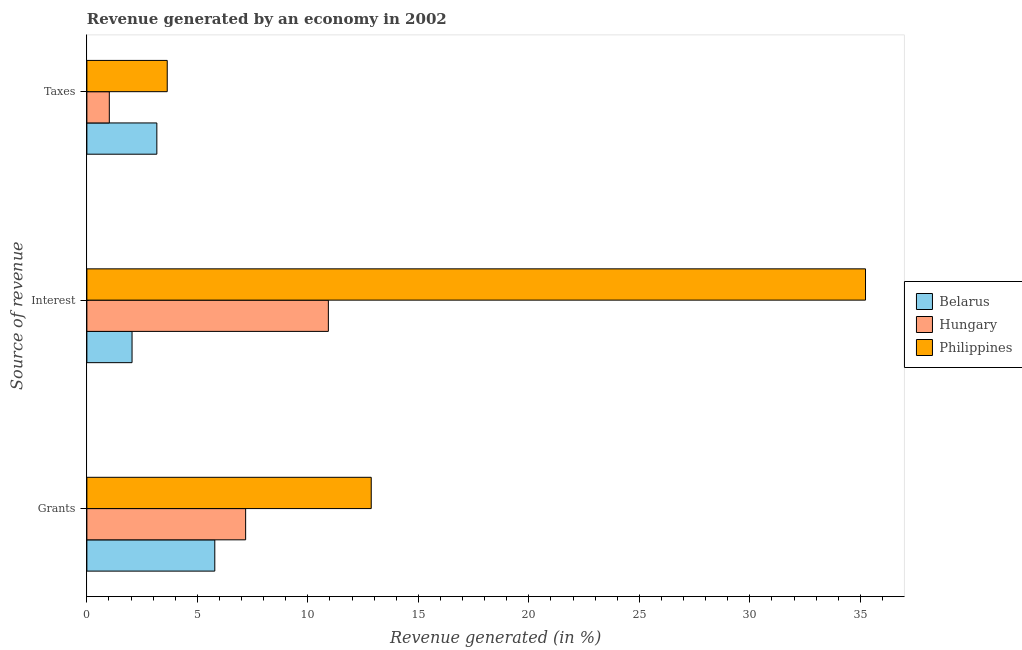How many different coloured bars are there?
Your answer should be very brief. 3. How many groups of bars are there?
Ensure brevity in your answer.  3. How many bars are there on the 1st tick from the bottom?
Give a very brief answer. 3. What is the label of the 1st group of bars from the top?
Provide a short and direct response. Taxes. What is the percentage of revenue generated by grants in Philippines?
Your answer should be compact. 12.87. Across all countries, what is the maximum percentage of revenue generated by taxes?
Your answer should be compact. 3.64. Across all countries, what is the minimum percentage of revenue generated by grants?
Keep it short and to the point. 5.79. In which country was the percentage of revenue generated by interest maximum?
Ensure brevity in your answer.  Philippines. In which country was the percentage of revenue generated by grants minimum?
Your answer should be compact. Belarus. What is the total percentage of revenue generated by grants in the graph?
Your answer should be very brief. 25.84. What is the difference between the percentage of revenue generated by interest in Hungary and that in Philippines?
Make the answer very short. -24.31. What is the difference between the percentage of revenue generated by grants in Philippines and the percentage of revenue generated by taxes in Hungary?
Offer a terse response. 11.85. What is the average percentage of revenue generated by taxes per country?
Your answer should be compact. 2.61. What is the difference between the percentage of revenue generated by taxes and percentage of revenue generated by interest in Philippines?
Provide a short and direct response. -31.6. In how many countries, is the percentage of revenue generated by interest greater than 32 %?
Provide a succinct answer. 1. What is the ratio of the percentage of revenue generated by interest in Philippines to that in Belarus?
Your answer should be compact. 17.24. What is the difference between the highest and the second highest percentage of revenue generated by grants?
Offer a very short reply. 5.68. What is the difference between the highest and the lowest percentage of revenue generated by grants?
Provide a succinct answer. 7.08. Is the sum of the percentage of revenue generated by interest in Hungary and Belarus greater than the maximum percentage of revenue generated by taxes across all countries?
Provide a succinct answer. Yes. What does the 3rd bar from the top in Grants represents?
Provide a short and direct response. Belarus. What does the 2nd bar from the bottom in Taxes represents?
Keep it short and to the point. Hungary. Is it the case that in every country, the sum of the percentage of revenue generated by grants and percentage of revenue generated by interest is greater than the percentage of revenue generated by taxes?
Give a very brief answer. Yes. How many countries are there in the graph?
Provide a succinct answer. 3. Where does the legend appear in the graph?
Your response must be concise. Center right. How many legend labels are there?
Provide a succinct answer. 3. How are the legend labels stacked?
Your answer should be very brief. Vertical. What is the title of the graph?
Offer a very short reply. Revenue generated by an economy in 2002. What is the label or title of the X-axis?
Your response must be concise. Revenue generated (in %). What is the label or title of the Y-axis?
Your answer should be compact. Source of revenue. What is the Revenue generated (in %) in Belarus in Grants?
Your answer should be very brief. 5.79. What is the Revenue generated (in %) in Hungary in Grants?
Ensure brevity in your answer.  7.18. What is the Revenue generated (in %) of Philippines in Grants?
Your response must be concise. 12.87. What is the Revenue generated (in %) of Belarus in Interest?
Keep it short and to the point. 2.04. What is the Revenue generated (in %) in Hungary in Interest?
Your answer should be compact. 10.93. What is the Revenue generated (in %) in Philippines in Interest?
Offer a terse response. 35.23. What is the Revenue generated (in %) in Belarus in Taxes?
Your answer should be compact. 3.17. What is the Revenue generated (in %) in Hungary in Taxes?
Ensure brevity in your answer.  1.02. What is the Revenue generated (in %) in Philippines in Taxes?
Provide a succinct answer. 3.64. Across all Source of revenue, what is the maximum Revenue generated (in %) of Belarus?
Offer a very short reply. 5.79. Across all Source of revenue, what is the maximum Revenue generated (in %) in Hungary?
Ensure brevity in your answer.  10.93. Across all Source of revenue, what is the maximum Revenue generated (in %) of Philippines?
Keep it short and to the point. 35.23. Across all Source of revenue, what is the minimum Revenue generated (in %) in Belarus?
Ensure brevity in your answer.  2.04. Across all Source of revenue, what is the minimum Revenue generated (in %) of Hungary?
Offer a very short reply. 1.02. Across all Source of revenue, what is the minimum Revenue generated (in %) in Philippines?
Your response must be concise. 3.64. What is the total Revenue generated (in %) in Belarus in the graph?
Offer a terse response. 11. What is the total Revenue generated (in %) of Hungary in the graph?
Your answer should be very brief. 19.13. What is the total Revenue generated (in %) in Philippines in the graph?
Keep it short and to the point. 51.74. What is the difference between the Revenue generated (in %) in Belarus in Grants and that in Interest?
Give a very brief answer. 3.74. What is the difference between the Revenue generated (in %) in Hungary in Grants and that in Interest?
Provide a short and direct response. -3.74. What is the difference between the Revenue generated (in %) of Philippines in Grants and that in Interest?
Your answer should be very brief. -22.37. What is the difference between the Revenue generated (in %) in Belarus in Grants and that in Taxes?
Provide a succinct answer. 2.62. What is the difference between the Revenue generated (in %) of Hungary in Grants and that in Taxes?
Provide a short and direct response. 6.17. What is the difference between the Revenue generated (in %) of Philippines in Grants and that in Taxes?
Your response must be concise. 9.23. What is the difference between the Revenue generated (in %) of Belarus in Interest and that in Taxes?
Make the answer very short. -1.12. What is the difference between the Revenue generated (in %) of Hungary in Interest and that in Taxes?
Make the answer very short. 9.91. What is the difference between the Revenue generated (in %) of Philippines in Interest and that in Taxes?
Your response must be concise. 31.6. What is the difference between the Revenue generated (in %) of Belarus in Grants and the Revenue generated (in %) of Hungary in Interest?
Make the answer very short. -5.14. What is the difference between the Revenue generated (in %) in Belarus in Grants and the Revenue generated (in %) in Philippines in Interest?
Offer a very short reply. -29.45. What is the difference between the Revenue generated (in %) of Hungary in Grants and the Revenue generated (in %) of Philippines in Interest?
Make the answer very short. -28.05. What is the difference between the Revenue generated (in %) of Belarus in Grants and the Revenue generated (in %) of Hungary in Taxes?
Your response must be concise. 4.77. What is the difference between the Revenue generated (in %) in Belarus in Grants and the Revenue generated (in %) in Philippines in Taxes?
Keep it short and to the point. 2.15. What is the difference between the Revenue generated (in %) of Hungary in Grants and the Revenue generated (in %) of Philippines in Taxes?
Make the answer very short. 3.55. What is the difference between the Revenue generated (in %) in Belarus in Interest and the Revenue generated (in %) in Hungary in Taxes?
Provide a short and direct response. 1.03. What is the difference between the Revenue generated (in %) in Belarus in Interest and the Revenue generated (in %) in Philippines in Taxes?
Give a very brief answer. -1.59. What is the difference between the Revenue generated (in %) of Hungary in Interest and the Revenue generated (in %) of Philippines in Taxes?
Your answer should be compact. 7.29. What is the average Revenue generated (in %) of Belarus per Source of revenue?
Provide a short and direct response. 3.67. What is the average Revenue generated (in %) in Hungary per Source of revenue?
Provide a succinct answer. 6.38. What is the average Revenue generated (in %) of Philippines per Source of revenue?
Ensure brevity in your answer.  17.25. What is the difference between the Revenue generated (in %) of Belarus and Revenue generated (in %) of Hungary in Grants?
Your answer should be compact. -1.4. What is the difference between the Revenue generated (in %) in Belarus and Revenue generated (in %) in Philippines in Grants?
Ensure brevity in your answer.  -7.08. What is the difference between the Revenue generated (in %) of Hungary and Revenue generated (in %) of Philippines in Grants?
Offer a very short reply. -5.68. What is the difference between the Revenue generated (in %) of Belarus and Revenue generated (in %) of Hungary in Interest?
Ensure brevity in your answer.  -8.88. What is the difference between the Revenue generated (in %) in Belarus and Revenue generated (in %) in Philippines in Interest?
Offer a terse response. -33.19. What is the difference between the Revenue generated (in %) in Hungary and Revenue generated (in %) in Philippines in Interest?
Your response must be concise. -24.31. What is the difference between the Revenue generated (in %) in Belarus and Revenue generated (in %) in Hungary in Taxes?
Ensure brevity in your answer.  2.15. What is the difference between the Revenue generated (in %) of Belarus and Revenue generated (in %) of Philippines in Taxes?
Offer a very short reply. -0.47. What is the difference between the Revenue generated (in %) of Hungary and Revenue generated (in %) of Philippines in Taxes?
Provide a short and direct response. -2.62. What is the ratio of the Revenue generated (in %) in Belarus in Grants to that in Interest?
Offer a terse response. 2.83. What is the ratio of the Revenue generated (in %) of Hungary in Grants to that in Interest?
Provide a succinct answer. 0.66. What is the ratio of the Revenue generated (in %) in Philippines in Grants to that in Interest?
Ensure brevity in your answer.  0.37. What is the ratio of the Revenue generated (in %) in Belarus in Grants to that in Taxes?
Make the answer very short. 1.83. What is the ratio of the Revenue generated (in %) in Hungary in Grants to that in Taxes?
Make the answer very short. 7.08. What is the ratio of the Revenue generated (in %) of Philippines in Grants to that in Taxes?
Make the answer very short. 3.54. What is the ratio of the Revenue generated (in %) of Belarus in Interest to that in Taxes?
Give a very brief answer. 0.65. What is the ratio of the Revenue generated (in %) in Hungary in Interest to that in Taxes?
Provide a short and direct response. 10.77. What is the ratio of the Revenue generated (in %) in Philippines in Interest to that in Taxes?
Provide a succinct answer. 9.69. What is the difference between the highest and the second highest Revenue generated (in %) of Belarus?
Your response must be concise. 2.62. What is the difference between the highest and the second highest Revenue generated (in %) of Hungary?
Provide a short and direct response. 3.74. What is the difference between the highest and the second highest Revenue generated (in %) of Philippines?
Offer a very short reply. 22.37. What is the difference between the highest and the lowest Revenue generated (in %) of Belarus?
Offer a terse response. 3.74. What is the difference between the highest and the lowest Revenue generated (in %) of Hungary?
Offer a very short reply. 9.91. What is the difference between the highest and the lowest Revenue generated (in %) in Philippines?
Ensure brevity in your answer.  31.6. 